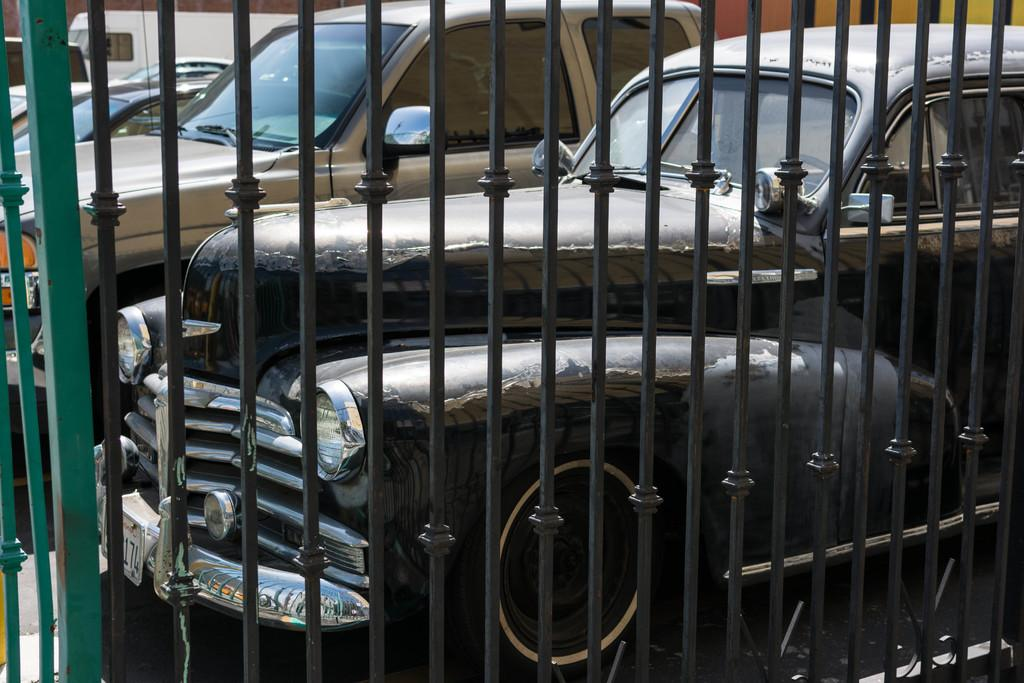What type of vehicles can be seen in the image? There are cars in the image. Can you describe the position of one of the vehicles? There is a vehicle parked in the image. What type of barrier is present in the image? There is a metal fence in the image. What type of yarn is being used to create the record in the image? There is no yarn or record present in the image. How many sheep can be seen grazing near the cars in the image? There are no sheep present in the image. 